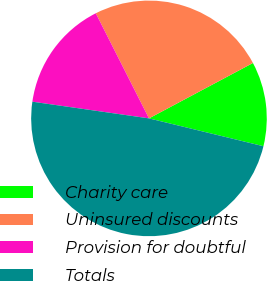Convert chart to OTSL. <chart><loc_0><loc_0><loc_500><loc_500><pie_chart><fcel>Charity care<fcel>Uninsured discounts<fcel>Provision for doubtful<fcel>Totals<nl><fcel>11.59%<fcel>24.66%<fcel>15.28%<fcel>48.46%<nl></chart> 